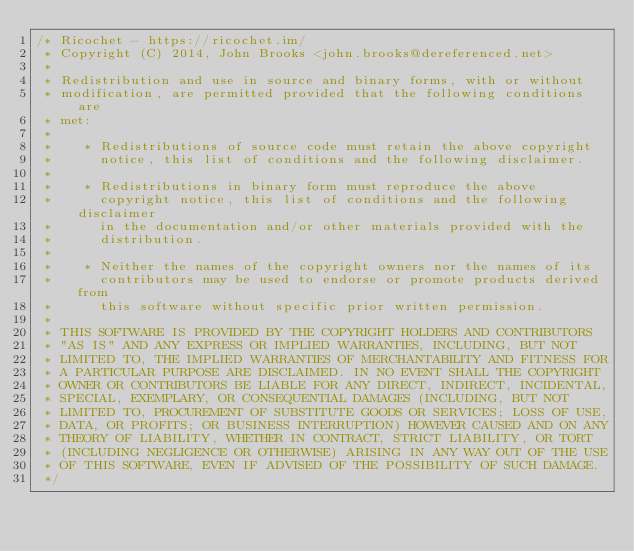<code> <loc_0><loc_0><loc_500><loc_500><_C_>/* Ricochet - https://ricochet.im/
 * Copyright (C) 2014, John Brooks <john.brooks@dereferenced.net>
 *
 * Redistribution and use in source and binary forms, with or without
 * modification, are permitted provided that the following conditions are
 * met:
 *
 *    * Redistributions of source code must retain the above copyright
 *      notice, this list of conditions and the following disclaimer.
 *
 *    * Redistributions in binary form must reproduce the above
 *      copyright notice, this list of conditions and the following disclaimer
 *      in the documentation and/or other materials provided with the
 *      distribution.
 *
 *    * Neither the names of the copyright owners nor the names of its
 *      contributors may be used to endorse or promote products derived from
 *      this software without specific prior written permission.
 *
 * THIS SOFTWARE IS PROVIDED BY THE COPYRIGHT HOLDERS AND CONTRIBUTORS
 * "AS IS" AND ANY EXPRESS OR IMPLIED WARRANTIES, INCLUDING, BUT NOT
 * LIMITED TO, THE IMPLIED WARRANTIES OF MERCHANTABILITY AND FITNESS FOR
 * A PARTICULAR PURPOSE ARE DISCLAIMED. IN NO EVENT SHALL THE COPYRIGHT
 * OWNER OR CONTRIBUTORS BE LIABLE FOR ANY DIRECT, INDIRECT, INCIDENTAL,
 * SPECIAL, EXEMPLARY, OR CONSEQUENTIAL DAMAGES (INCLUDING, BUT NOT
 * LIMITED TO, PROCUREMENT OF SUBSTITUTE GOODS OR SERVICES; LOSS OF USE,
 * DATA, OR PROFITS; OR BUSINESS INTERRUPTION) HOWEVER CAUSED AND ON ANY
 * THEORY OF LIABILITY, WHETHER IN CONTRACT, STRICT LIABILITY, OR TORT
 * (INCLUDING NEGLIGENCE OR OTHERWISE) ARISING IN ANY WAY OUT OF THE USE
 * OF THIS SOFTWARE, EVEN IF ADVISED OF THE POSSIBILITY OF SUCH DAMAGE.
 */
</code> 